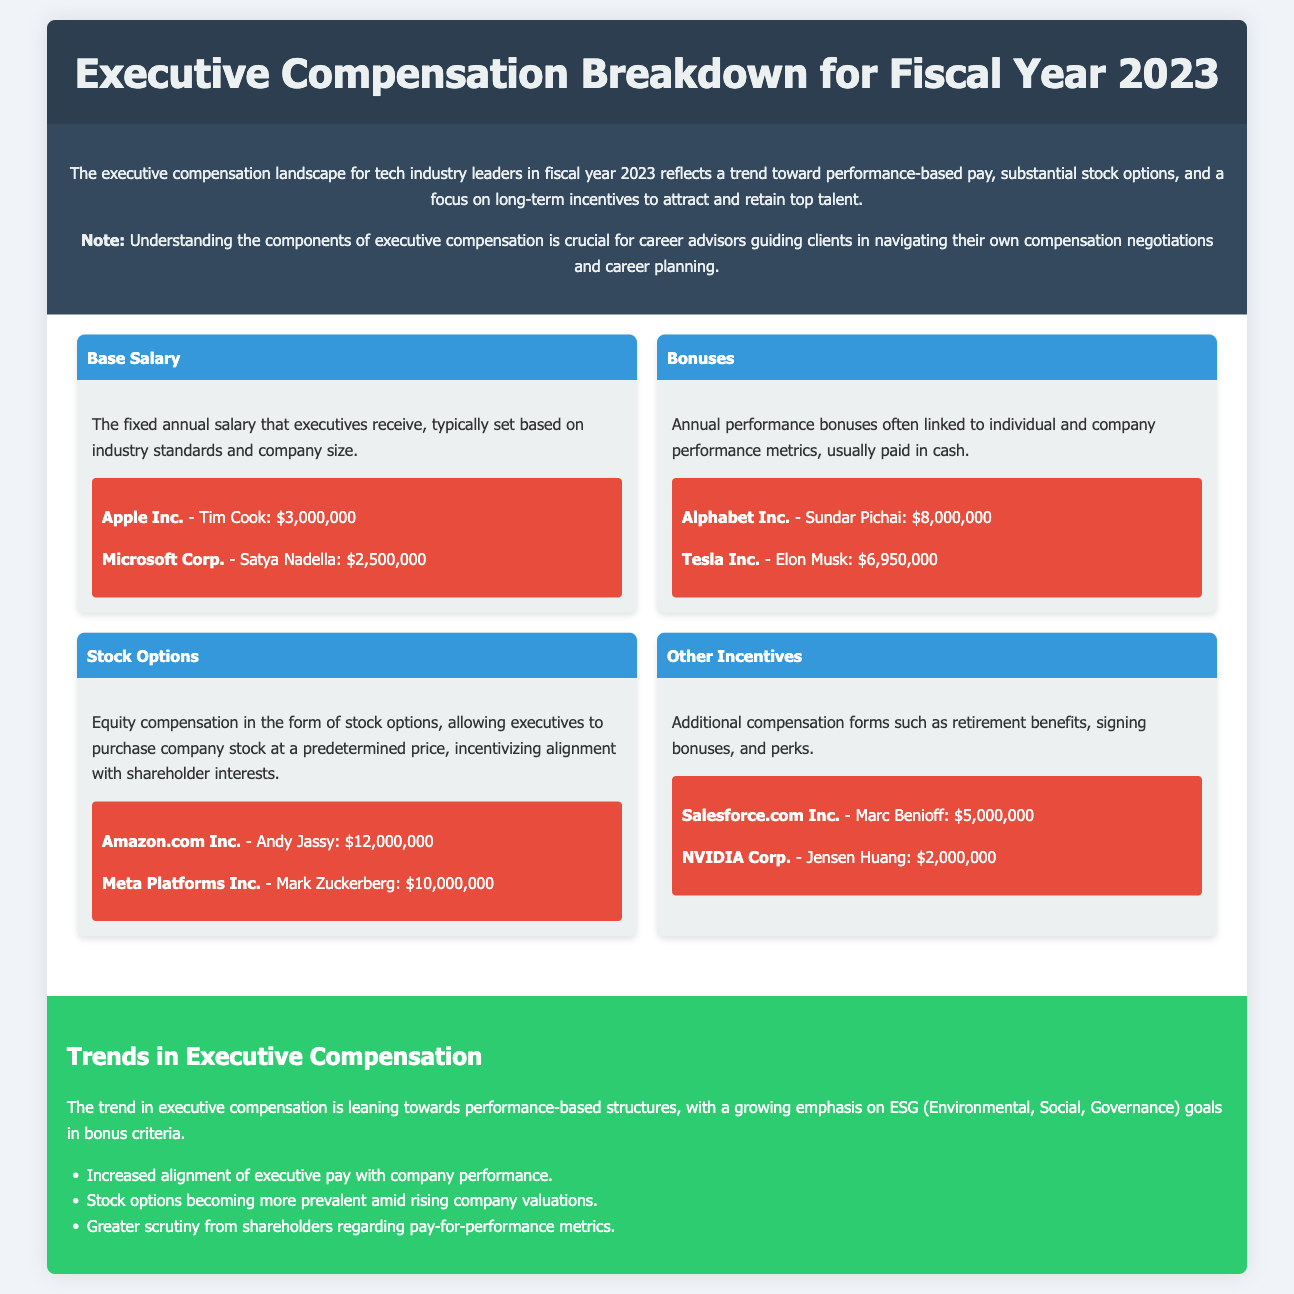What is Tim Cook's base salary? The document provides Tim Cook's base salary under the "Base Salary" component, which is $3,000,000.
Answer: $3,000,000 What is Sundar Pichai's bonus? The document states Sundar Pichai's annual performance bonus is $8,000,000 under the "Bonuses" component.
Answer: $8,000,000 How much in stock options does Andy Jassy receive? The document mentions that Andy Jassy's stock options amount to $12,000,000 under the "Stock Options" component.
Answer: $12,000,000 What are the other incentives for Marc Benioff? The document lists Marc Benioff's other incentives as $5,000,000 under "Other Incentives."
Answer: $5,000,000 What is the overall trend in executive compensation for 2023? The document highlights a trend towards performance-based pay and ESG goals.
Answer: Performance-based pay What is the focus of executive compensation structures in 2023? The document states a focus on attracting and retaining top talent through long-term incentives.
Answer: Attracting and retaining top talent Which company does Jensen Huang represent? The document provides Jensen Huang's name under the "Other Incentives" component, showing him to be from NVIDIA Corp.
Answer: NVIDIA Corp What is a common form of compensation mentioned besides salary? The document discusses various compensation forms, notably bonuses, as a common element aside from salaries.
Answer: Bonuses What is a significant focus area in bonus criteria for executives? The document indicates a growing emphasis on ESG (Environmental, Social, Governance) goals in bonus criteria.
Answer: ESG goals 